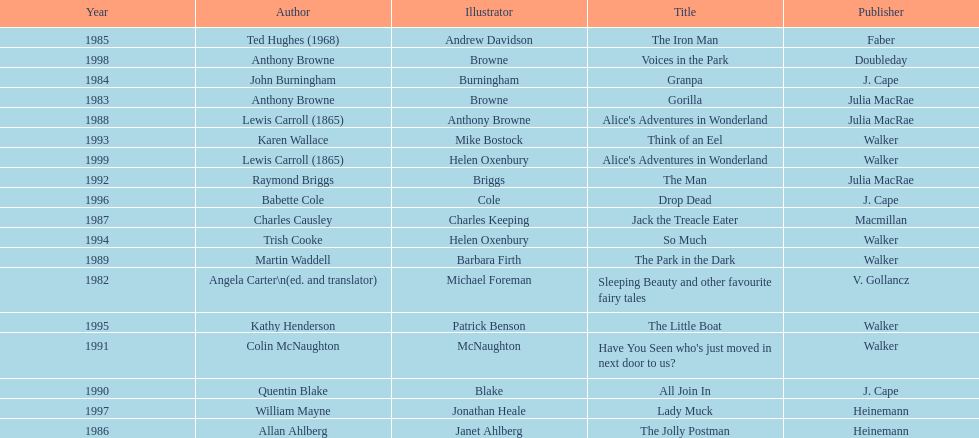How many number of titles are listed for the year 1991? 1. 